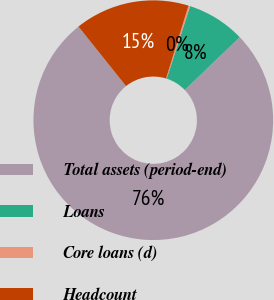<chart> <loc_0><loc_0><loc_500><loc_500><pie_chart><fcel>Total assets (period-end)<fcel>Loans<fcel>Core loans (d)<fcel>Headcount<nl><fcel>76.44%<fcel>7.85%<fcel>0.23%<fcel>15.47%<nl></chart> 